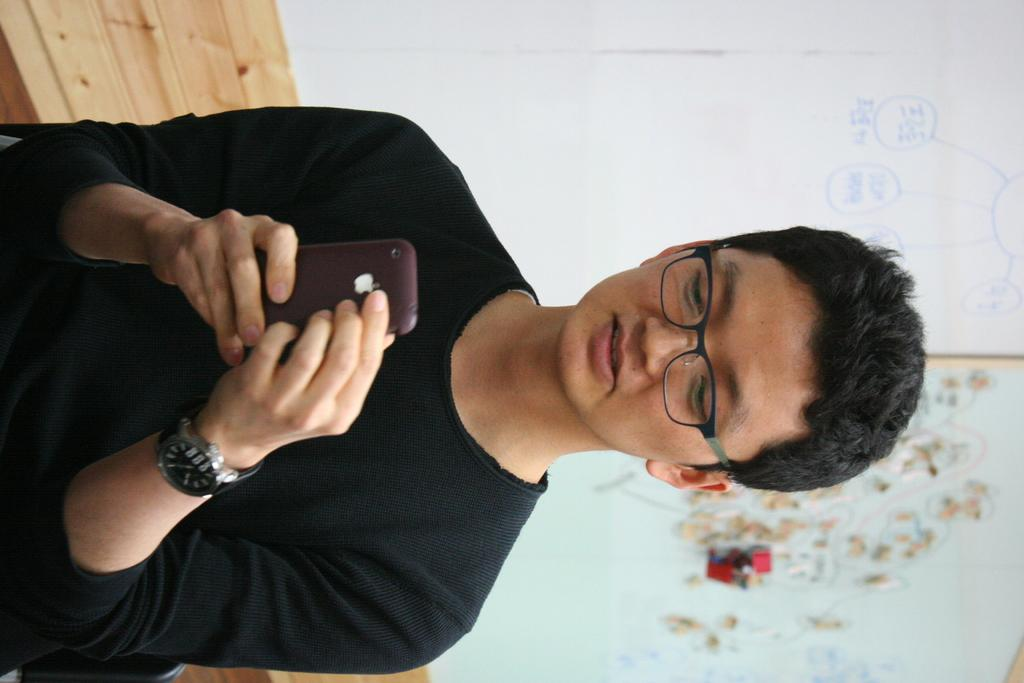What is the person in the image doing? The person in the image is using a mobile. What can be seen behind the person? There is a wooden bench behind the person. What is on the wall behind the bench? There is a board with text on the wall behind the bench. What type of cherry is being recorded on the mobile in the image? There is no cherry present in the image, and the mobile is not being used to record anything. 